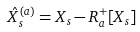<formula> <loc_0><loc_0><loc_500><loc_500>\hat { X } ^ { ( a ) } _ { s } = X _ { s } - R ^ { + } _ { a } [ X _ { s } ]</formula> 